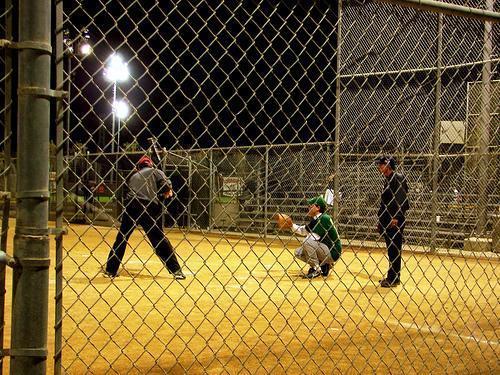How many people are visible?
Give a very brief answer. 3. How many people are visible?
Give a very brief answer. 3. 